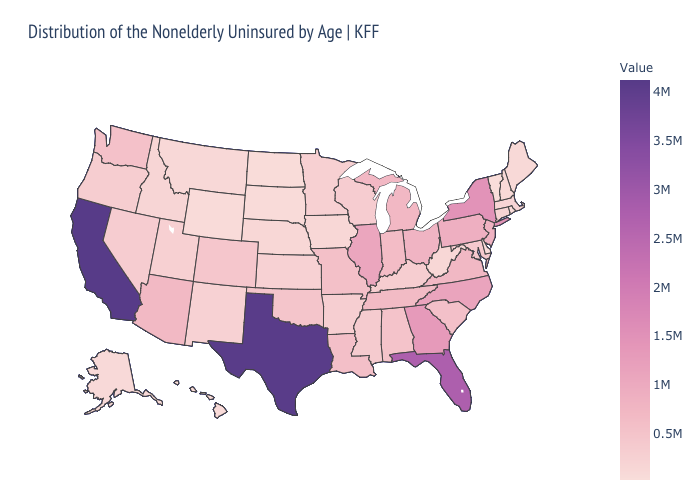Does Louisiana have the highest value in the USA?
Quick response, please. No. Is the legend a continuous bar?
Be succinct. Yes. Does Texas have the highest value in the South?
Answer briefly. Yes. Does New Jersey have a higher value than Texas?
Quick response, please. No. Is the legend a continuous bar?
Give a very brief answer. Yes. Among the states that border Connecticut , which have the highest value?
Give a very brief answer. New York. 